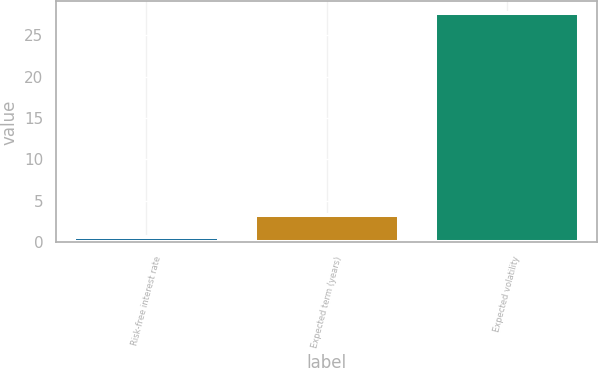Convert chart. <chart><loc_0><loc_0><loc_500><loc_500><bar_chart><fcel>Risk-free interest rate<fcel>Expected term (years)<fcel>Expected volatility<nl><fcel>0.59<fcel>3.3<fcel>27.72<nl></chart> 